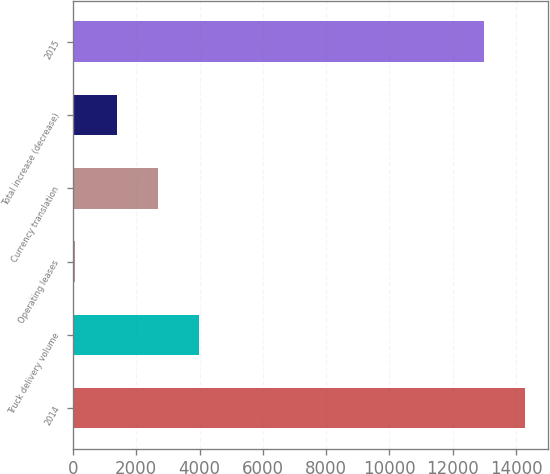Convert chart to OTSL. <chart><loc_0><loc_0><loc_500><loc_500><bar_chart><fcel>2014<fcel>Truck delivery volume<fcel>Operating leases<fcel>Currency translation<fcel>Total increase (decrease)<fcel>2015<nl><fcel>14281.3<fcel>3984.57<fcel>75.6<fcel>2681.58<fcel>1378.59<fcel>12978.3<nl></chart> 